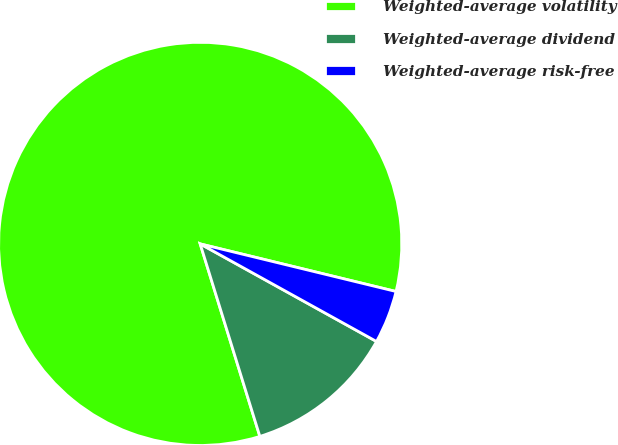<chart> <loc_0><loc_0><loc_500><loc_500><pie_chart><fcel>Weighted-average volatility<fcel>Weighted-average dividend<fcel>Weighted-average risk-free<nl><fcel>83.58%<fcel>12.17%<fcel>4.25%<nl></chart> 